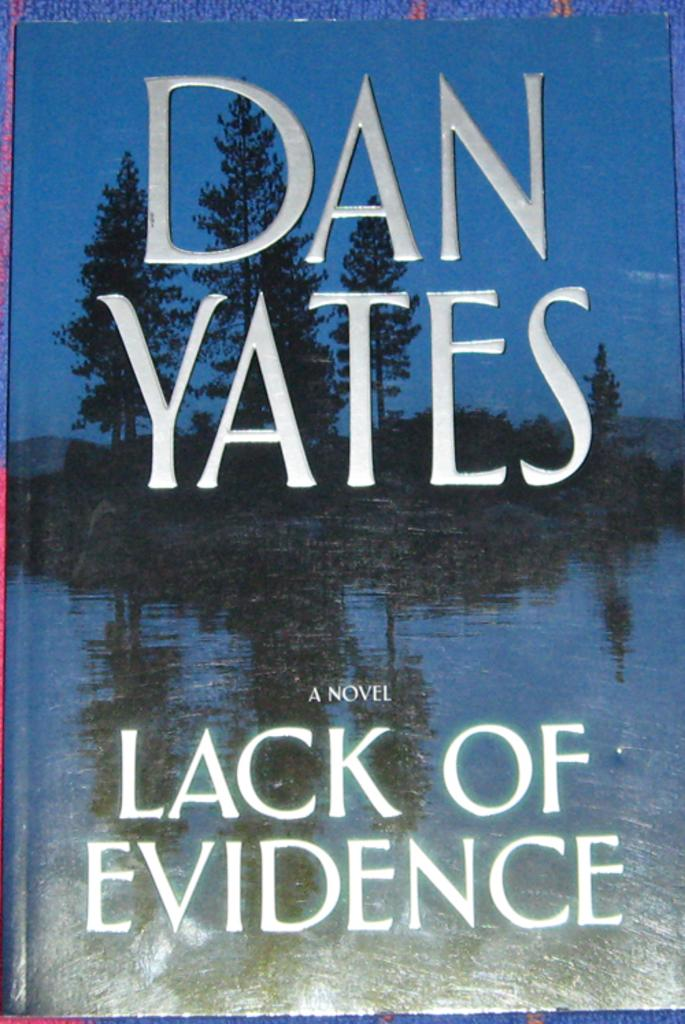<image>
Relay a brief, clear account of the picture shown. A book called Lack of Evidence with a lake on the cover by Dan Yates. 